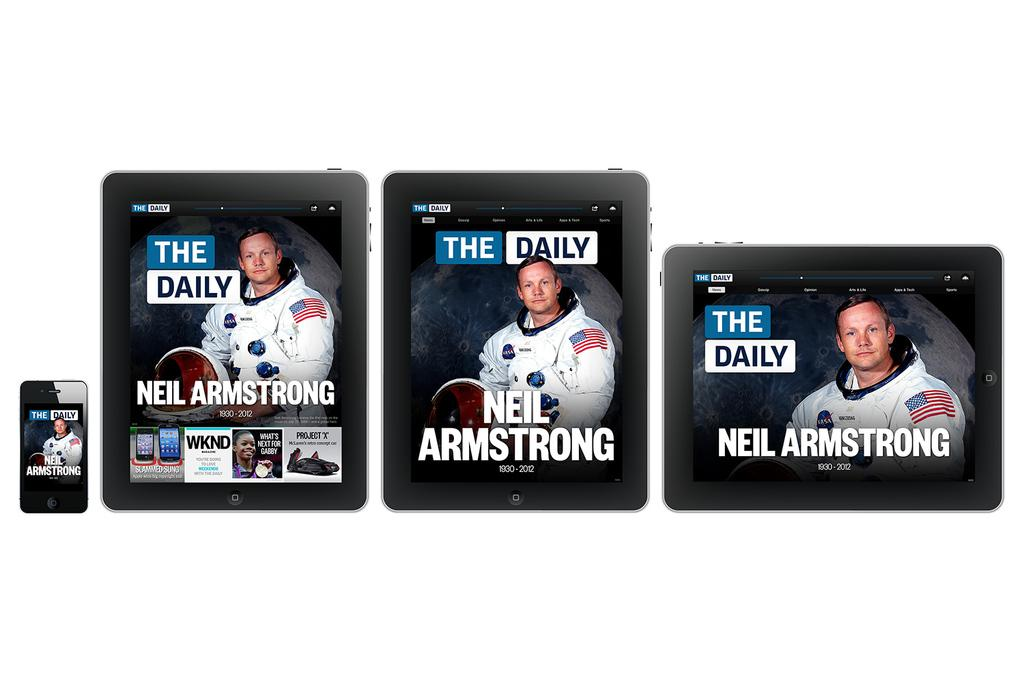What electronic devices are present in the image? There are three iPads and one iPhone in the image. What is displayed on the electronic devices? A person with a white dress is visible on the iPads and iPhone. What else can be seen on the electronic devices besides the person? Text is present on the iPads and iPhone. What is the color of the surface in the background of the image? There is a white surface in the background of the image. How does the heat affect the person on the electronic devices in the image? There is no mention of heat in the image, and the person is displayed on the electronic devices, not physically present. 